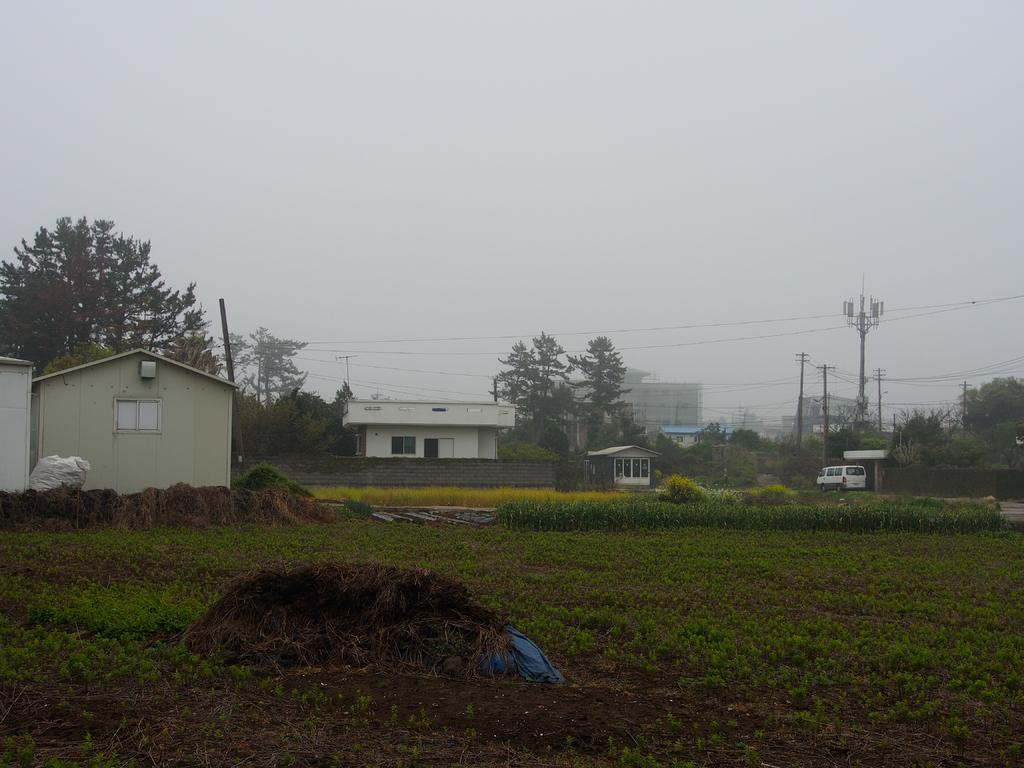What type of structures can be seen in the image? There are buildings in the image. What type of vegetation is present in the image? There are trees and grass in the image. What else can be seen in the image besides buildings and vegetation? There are poles with wires in the image. What is visible in the background of the image? The sky is visible in the background of the image. Can you tell me how many squirrels are sitting on the scissors in the image? There are no squirrels or scissors present in the image. How many spiders are visible on the poles with wires in the image? There are no spiders visible on the poles with wires in the image. 